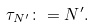<formula> <loc_0><loc_0><loc_500><loc_500>\tau _ { N ^ { \prime } } \colon = N ^ { \prime } .</formula> 